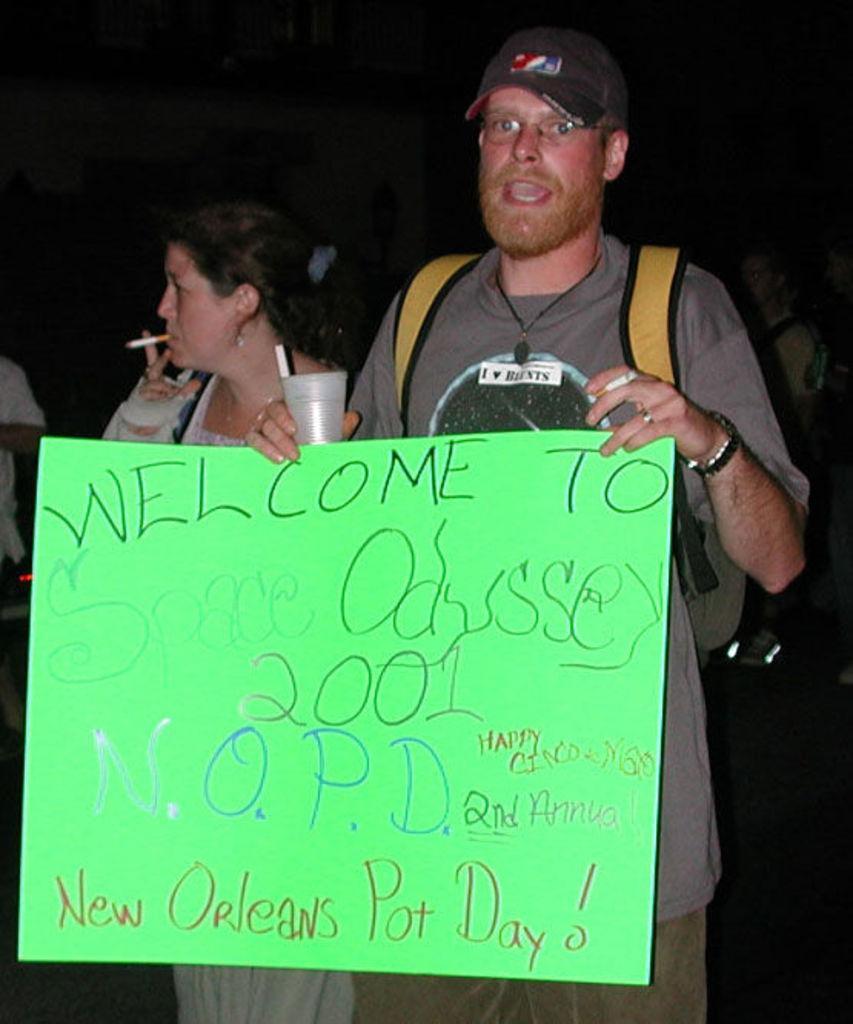What is the man in the image holding? The man is holding a glass and a board in the image. What is the woman in the image holding? The woman is holding a cigarette in the image. Can you describe the background of the image? The background of the image is dark. How does the man help the woman blow out the quarter in the image? There is no quarter or blowing activity present in the image. 